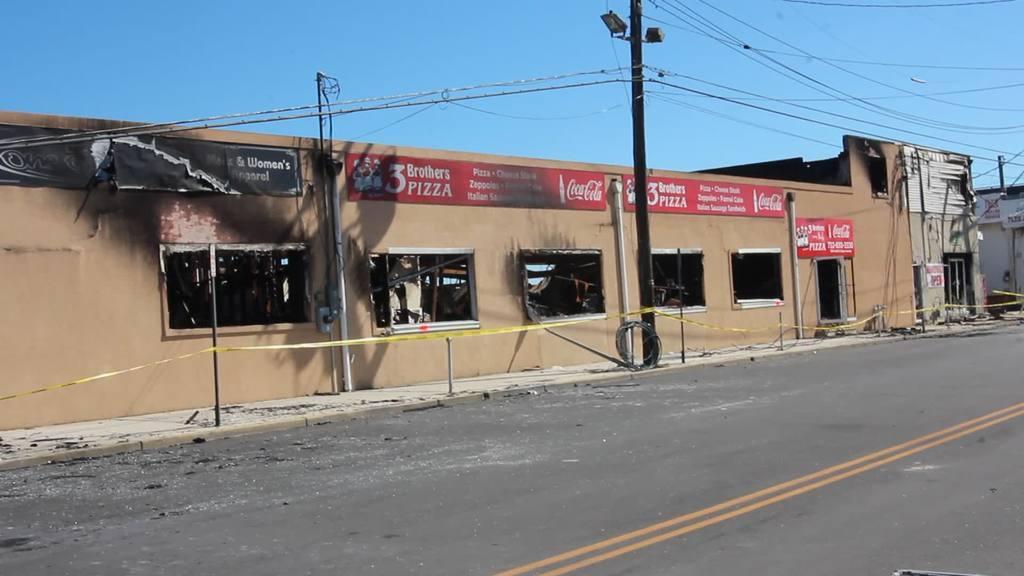How would you summarize this image in a sentence or two? In this image we can see a building with a group of windows, doors, some poles and sign boards with some text. In the foreground we can see a ribbon, light pole with cables, pathway. In the background, we can see the sky. 